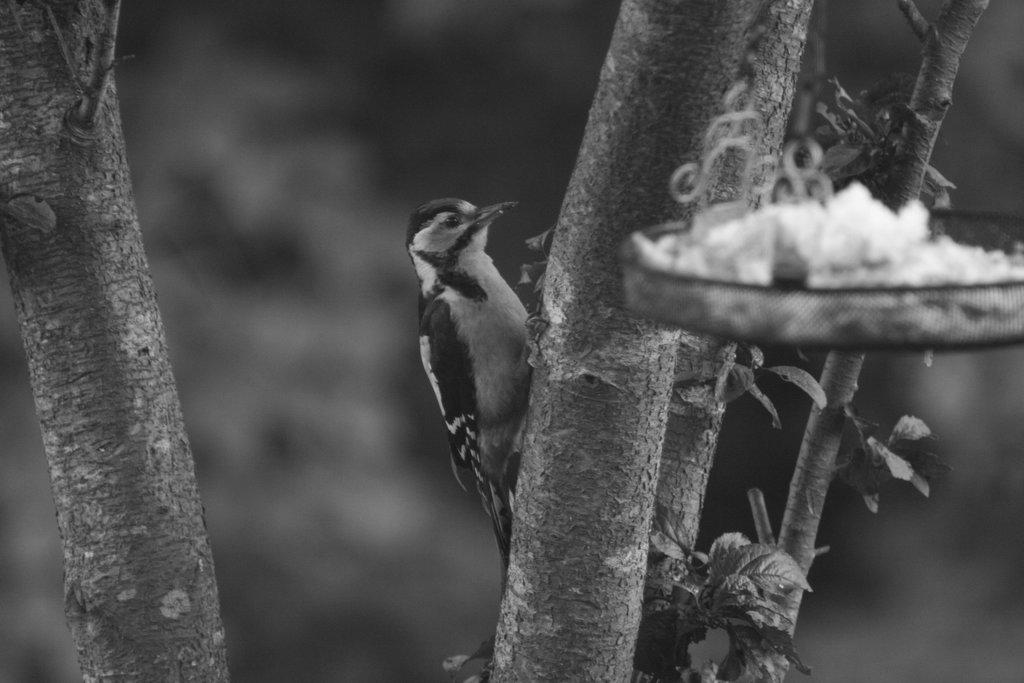What is the color scheme of the image? The image is black and white. What can be seen in the image besides the black and white color scheme? There is a bird on a branch of a tree in the image. What is located on the right side of the image? There is an object on the right side of the image. How would you describe the background of the image? The background of the image is blurred. How many crackers are visible in the image? There are no crackers present in the image. What type of button is attached to the bird's wing in the image? There is no button attached to the bird's wing in the image; it is a bird in a natural setting. 